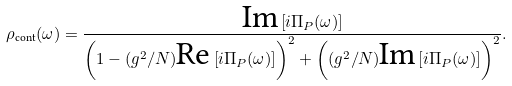Convert formula to latex. <formula><loc_0><loc_0><loc_500><loc_500>\rho _ { \text {cont} } ( \omega ) = \frac { \text {Im} \left [ i \Pi _ { P } ( \omega ) \right ] } { \left ( 1 - ( g ^ { 2 } / N ) \text {Re} \left [ i \Pi _ { P } ( \omega ) \right ] \right ) ^ { 2 } + \left ( ( g ^ { 2 } / N ) \text {Im} \left [ i \Pi _ { P } ( \omega ) \right ] \right ) ^ { 2 } } .</formula> 